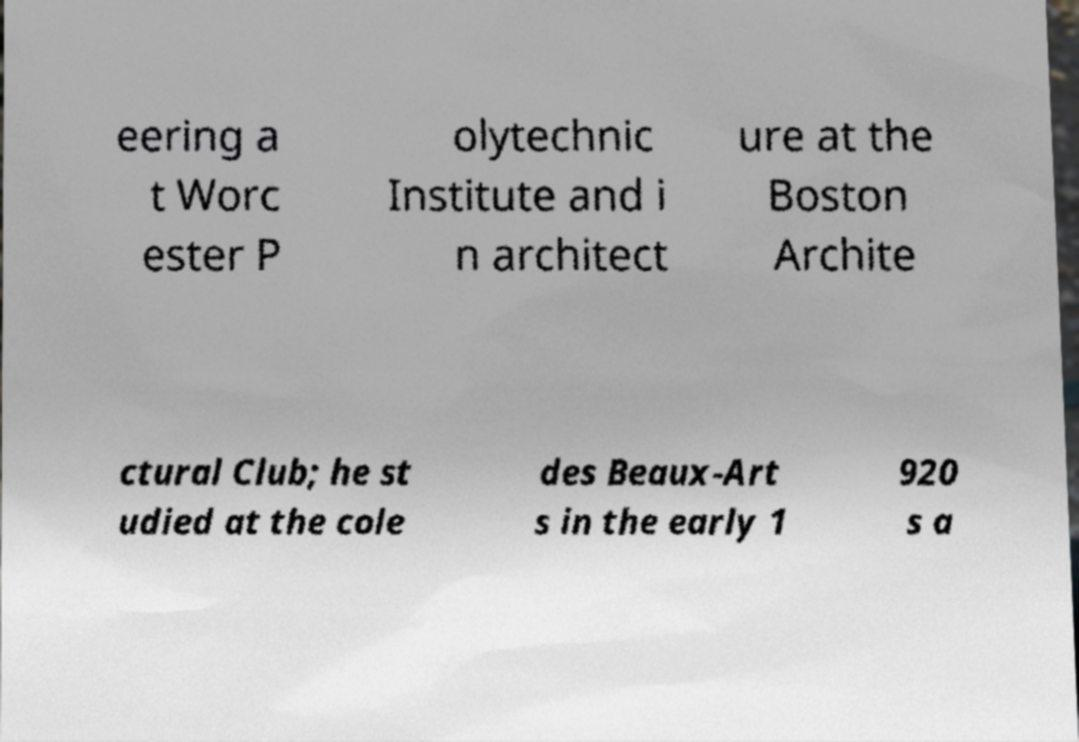Can you read and provide the text displayed in the image?This photo seems to have some interesting text. Can you extract and type it out for me? eering a t Worc ester P olytechnic Institute and i n architect ure at the Boston Archite ctural Club; he st udied at the cole des Beaux-Art s in the early 1 920 s a 